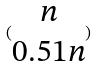<formula> <loc_0><loc_0><loc_500><loc_500>( \begin{matrix} n \\ 0 . 5 1 n \end{matrix} )</formula> 